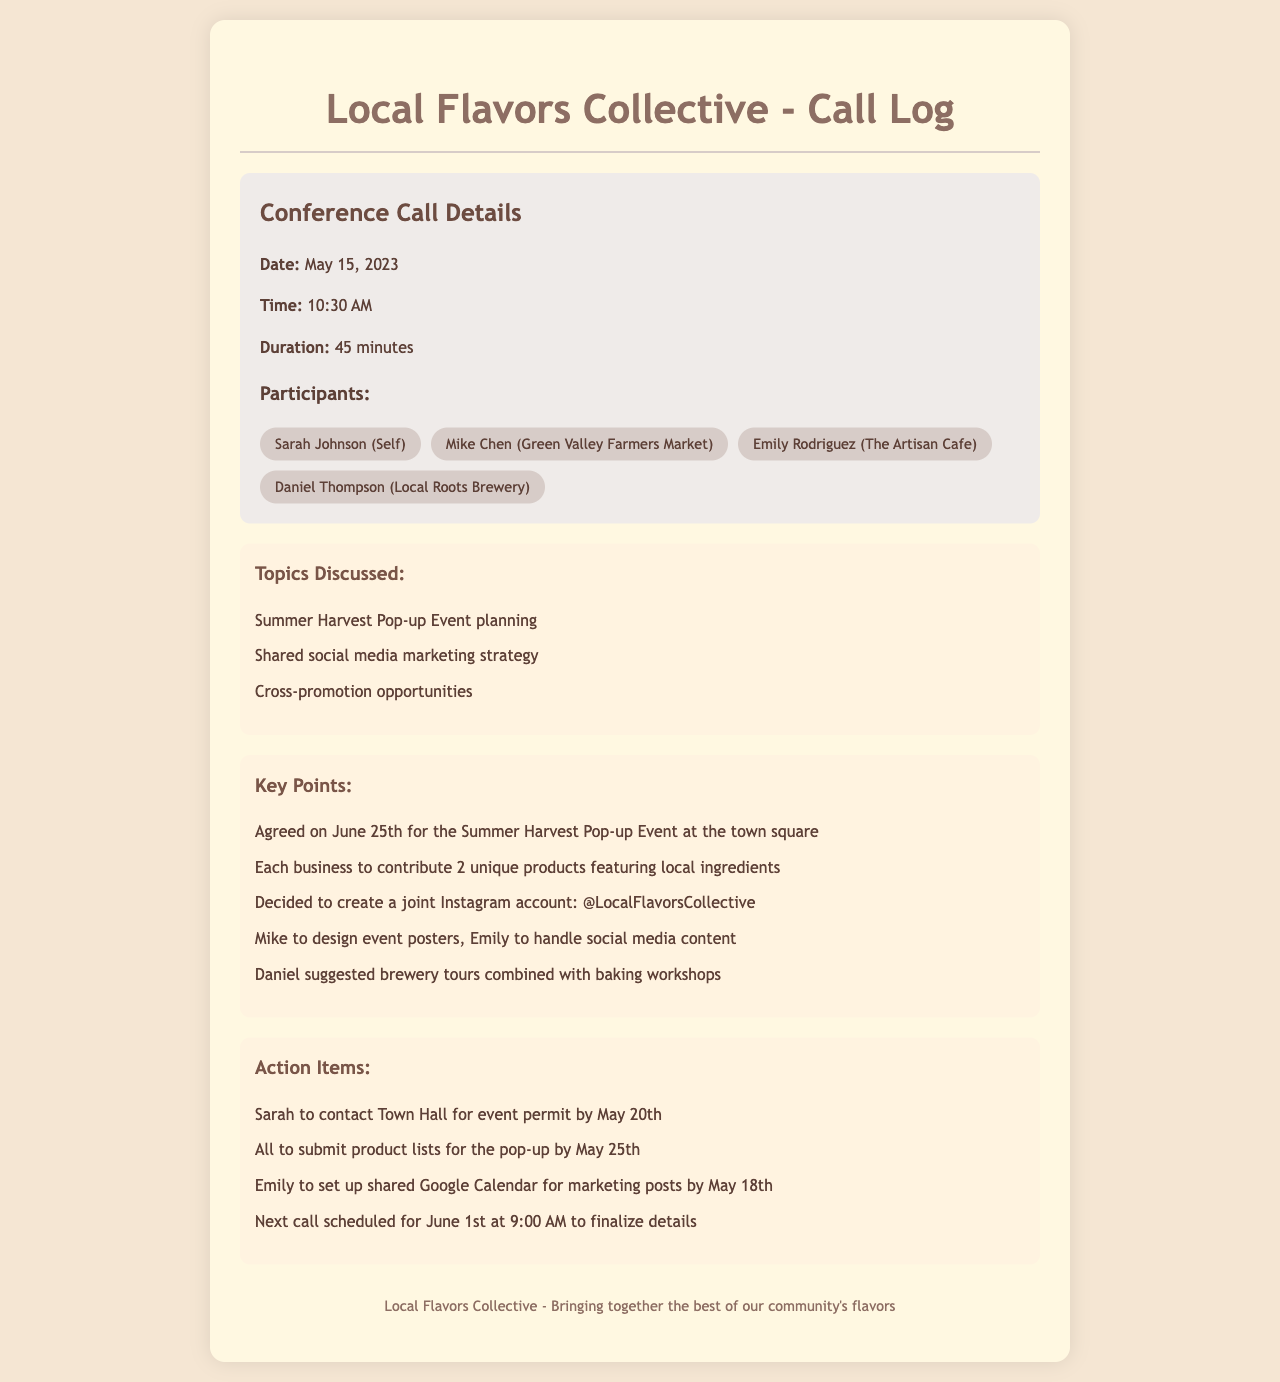what is the date of the conference call? The date is specified at the beginning of the call log, detailing when the conference call took place.
Answer: May 15, 2023 who is the participant from the Artisan Cafe? The document lists all participants, highlighting their respective businesses.
Answer: Emily Rodriguez what is the duration of the conference call? The duration is explicitly stated in the call log, indicating how long the call lasted.
Answer: 45 minutes what is the agreed date for the Summer Harvest Pop-up Event? A key point from the discussion indicates the agreed date for the event, which is a crucial detail from the call.
Answer: June 25th who is responsible for designing event posters? This information is a discussed action item, reflecting the tasks assigned to each participant during the call.
Answer: Mike how many unique products will each business contribute? This detail is outlined in the key points, summarizing the collaborative effort discussed among the participants.
Answer: 2 unique products when is the next call scheduled? The date and time for the next conference call is included in the action items section, indicating future communication plans.
Answer: June 1st at 9:00 AM what social media platform is being used for joint marketing? The participants decided on a specific platform for their collaborative marketing efforts, mentioned in the key points.
Answer: Instagram how many participants were on the call? The total number of participants can be determined from the participant section of the document, giving insight into the size of the meeting.
Answer: 4 participants 